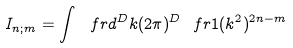Convert formula to latex. <formula><loc_0><loc_0><loc_500><loc_500>I _ { n ; m } = \int \ f r { d ^ { D } k } { ( 2 \pi ) ^ { D } } \ f r { 1 } { ( k ^ { 2 } ) ^ { 2 n - m } }</formula> 